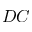<formula> <loc_0><loc_0><loc_500><loc_500>D C</formula> 